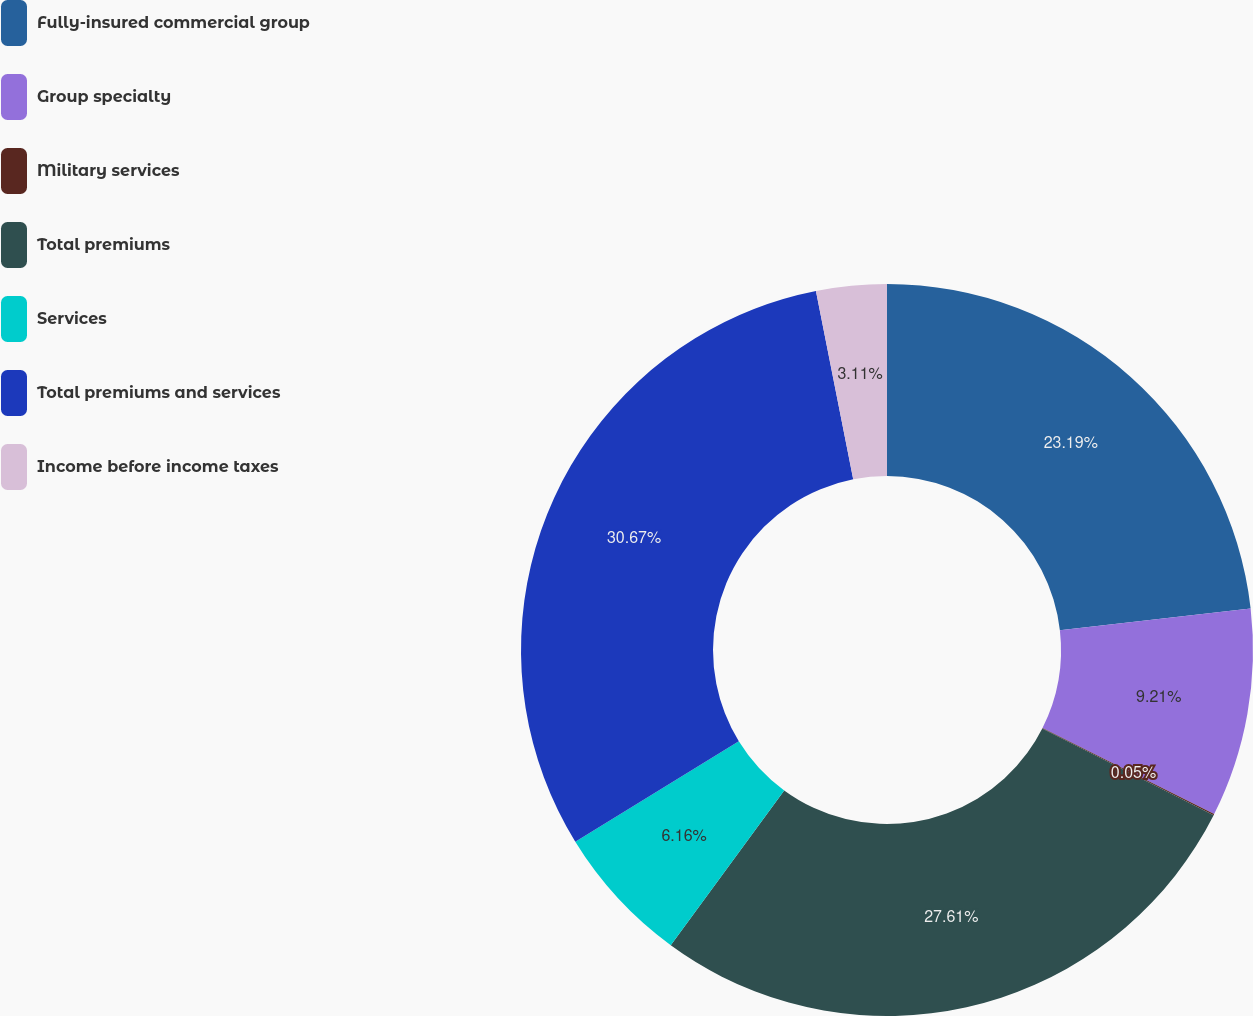Convert chart to OTSL. <chart><loc_0><loc_0><loc_500><loc_500><pie_chart><fcel>Fully-insured commercial group<fcel>Group specialty<fcel>Military services<fcel>Total premiums<fcel>Services<fcel>Total premiums and services<fcel>Income before income taxes<nl><fcel>23.19%<fcel>9.21%<fcel>0.05%<fcel>27.61%<fcel>6.16%<fcel>30.67%<fcel>3.11%<nl></chart> 